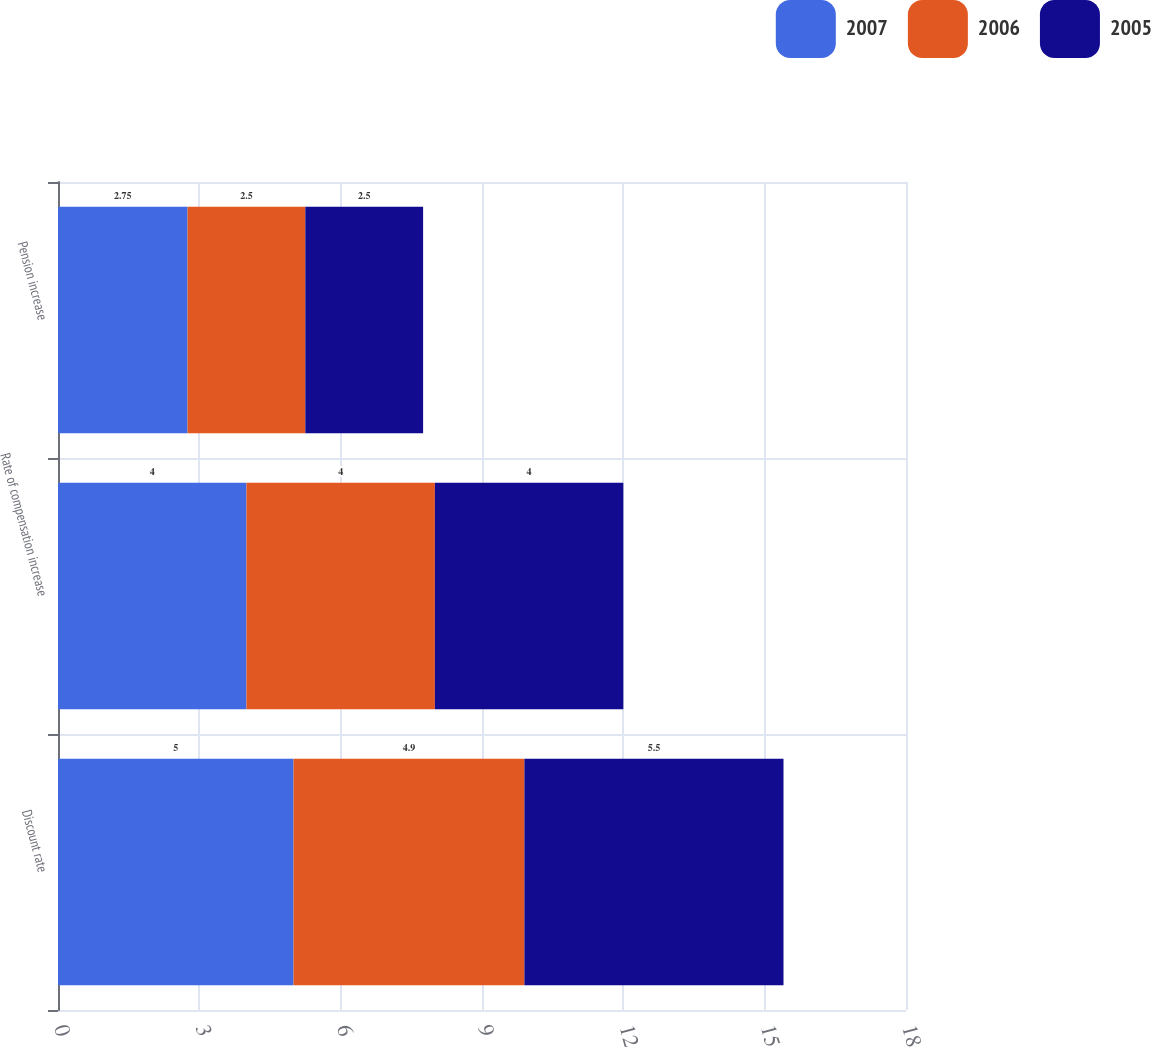Convert chart. <chart><loc_0><loc_0><loc_500><loc_500><stacked_bar_chart><ecel><fcel>Discount rate<fcel>Rate of compensation increase<fcel>Pension increase<nl><fcel>2007<fcel>5<fcel>4<fcel>2.75<nl><fcel>2006<fcel>4.9<fcel>4<fcel>2.5<nl><fcel>2005<fcel>5.5<fcel>4<fcel>2.5<nl></chart> 